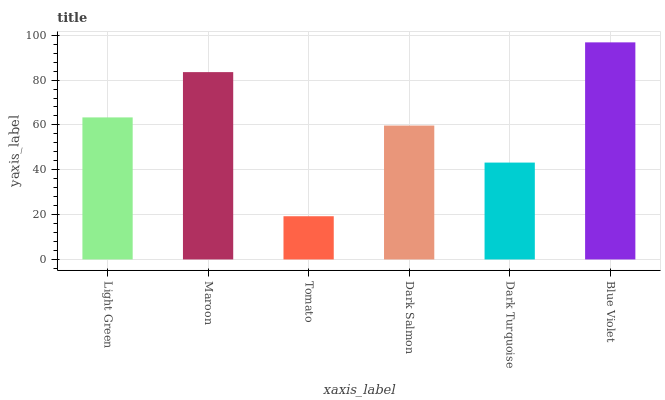Is Tomato the minimum?
Answer yes or no. Yes. Is Blue Violet the maximum?
Answer yes or no. Yes. Is Maroon the minimum?
Answer yes or no. No. Is Maroon the maximum?
Answer yes or no. No. Is Maroon greater than Light Green?
Answer yes or no. Yes. Is Light Green less than Maroon?
Answer yes or no. Yes. Is Light Green greater than Maroon?
Answer yes or no. No. Is Maroon less than Light Green?
Answer yes or no. No. Is Light Green the high median?
Answer yes or no. Yes. Is Dark Salmon the low median?
Answer yes or no. Yes. Is Dark Salmon the high median?
Answer yes or no. No. Is Light Green the low median?
Answer yes or no. No. 